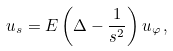Convert formula to latex. <formula><loc_0><loc_0><loc_500><loc_500>u _ { s } = E \left ( \Delta - \frac { 1 } { s ^ { 2 } } \right ) u _ { \varphi } \, ,</formula> 